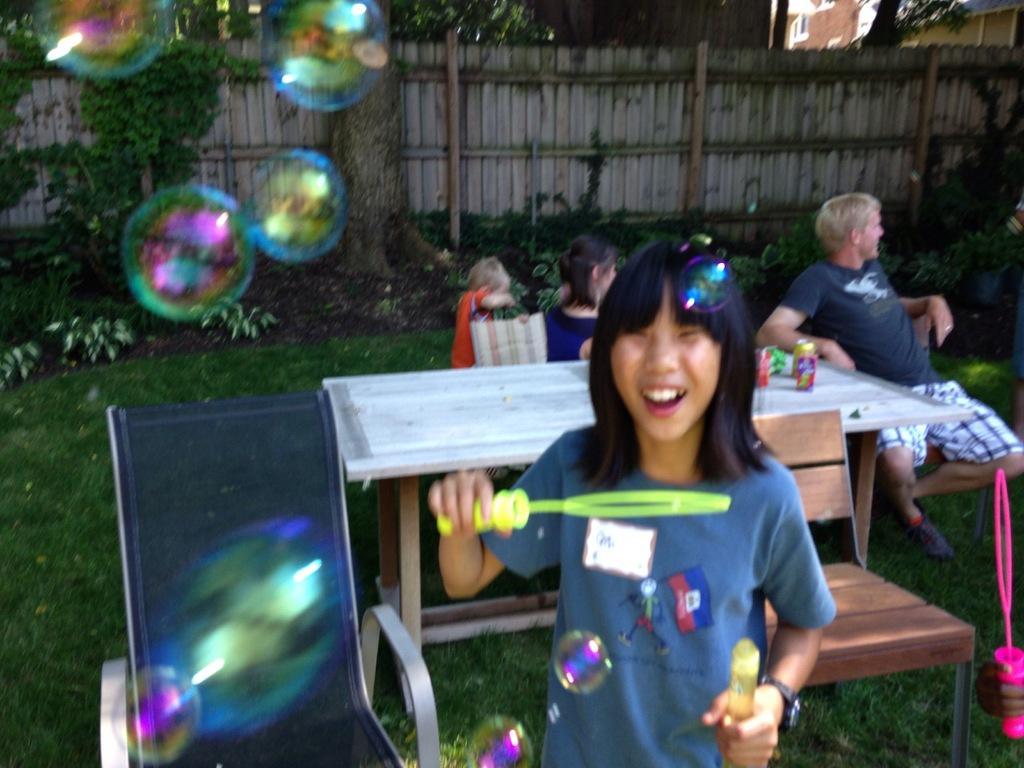Could you give a brief overview of what you see in this image? There is a table. There is a coke and chips packet on a table. In the center we have a woman. She is playing a bubble game. In the background we can there is a people sitting in a chair,tree and fencing wall. 